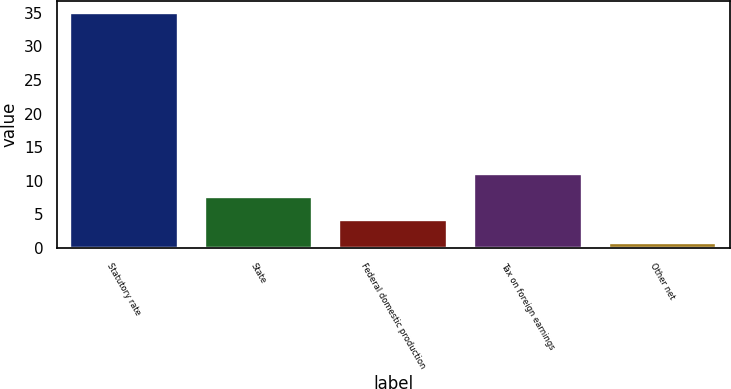Convert chart. <chart><loc_0><loc_0><loc_500><loc_500><bar_chart><fcel>Statutory rate<fcel>State<fcel>Federal domestic production<fcel>Tax on foreign earnings<fcel>Other net<nl><fcel>35<fcel>7.64<fcel>4.22<fcel>11.06<fcel>0.8<nl></chart> 